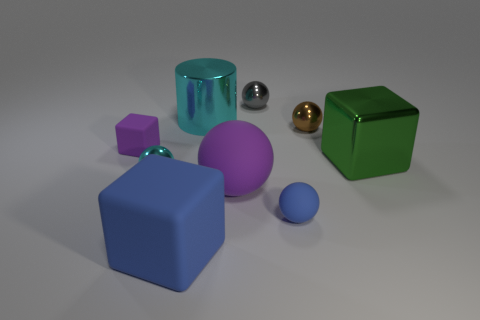Does the large ball have the same color as the small block?
Provide a succinct answer. Yes. There is a big rubber object that is in front of the blue sphere; is its color the same as the small matte sphere?
Provide a succinct answer. Yes. What shape is the large blue object that is the same material as the purple ball?
Offer a very short reply. Cube. What is the color of the tiny thing that is both left of the gray object and on the right side of the tiny purple rubber thing?
Offer a very short reply. Cyan. What is the size of the cyan object that is in front of the green object behind the large blue matte cube?
Offer a very short reply. Small. Is there a small shiny sphere of the same color as the metal cylinder?
Your answer should be very brief. Yes. Is the number of green metal blocks that are behind the cyan ball the same as the number of metal objects?
Provide a succinct answer. No. How many small brown balls are there?
Your answer should be compact. 1. What shape is the big object that is both in front of the tiny block and behind the tiny cyan object?
Your response must be concise. Cube. There is a small rubber thing in front of the big green thing; is it the same color as the large cube that is on the left side of the large cyan cylinder?
Provide a succinct answer. Yes. 